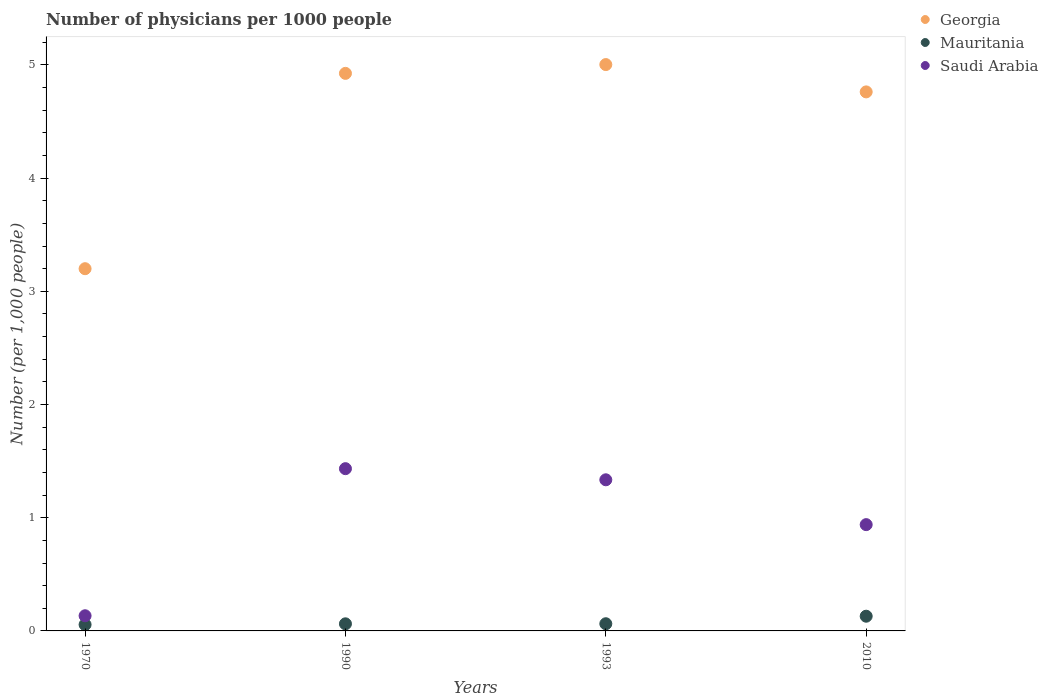How many different coloured dotlines are there?
Your answer should be compact. 3. Is the number of dotlines equal to the number of legend labels?
Offer a very short reply. Yes. What is the number of physicians in Mauritania in 1993?
Provide a succinct answer. 0.06. Across all years, what is the maximum number of physicians in Saudi Arabia?
Keep it short and to the point. 1.43. Across all years, what is the minimum number of physicians in Georgia?
Make the answer very short. 3.2. In which year was the number of physicians in Mauritania maximum?
Make the answer very short. 2010. In which year was the number of physicians in Georgia minimum?
Ensure brevity in your answer.  1970. What is the total number of physicians in Georgia in the graph?
Your answer should be very brief. 17.89. What is the difference between the number of physicians in Saudi Arabia in 1993 and that in 2010?
Your answer should be compact. 0.4. What is the difference between the number of physicians in Saudi Arabia in 1970 and the number of physicians in Georgia in 1990?
Offer a terse response. -4.79. What is the average number of physicians in Saudi Arabia per year?
Offer a very short reply. 0.96. In the year 1990, what is the difference between the number of physicians in Georgia and number of physicians in Mauritania?
Offer a very short reply. 4.86. What is the ratio of the number of physicians in Saudi Arabia in 1970 to that in 2010?
Your answer should be compact. 0.14. Is the difference between the number of physicians in Georgia in 1990 and 1993 greater than the difference between the number of physicians in Mauritania in 1990 and 1993?
Provide a succinct answer. No. What is the difference between the highest and the second highest number of physicians in Mauritania?
Your answer should be very brief. 0.07. What is the difference between the highest and the lowest number of physicians in Georgia?
Ensure brevity in your answer.  1.8. What is the difference between two consecutive major ticks on the Y-axis?
Provide a short and direct response. 1. How are the legend labels stacked?
Your response must be concise. Vertical. What is the title of the graph?
Offer a terse response. Number of physicians per 1000 people. Does "Turkmenistan" appear as one of the legend labels in the graph?
Offer a terse response. No. What is the label or title of the X-axis?
Your response must be concise. Years. What is the label or title of the Y-axis?
Keep it short and to the point. Number (per 1,0 people). What is the Number (per 1,000 people) in Georgia in 1970?
Your response must be concise. 3.2. What is the Number (per 1,000 people) in Mauritania in 1970?
Offer a terse response. 0.06. What is the Number (per 1,000 people) of Saudi Arabia in 1970?
Offer a very short reply. 0.13. What is the Number (per 1,000 people) in Georgia in 1990?
Your answer should be compact. 4.93. What is the Number (per 1,000 people) of Mauritania in 1990?
Offer a terse response. 0.06. What is the Number (per 1,000 people) in Saudi Arabia in 1990?
Offer a terse response. 1.43. What is the Number (per 1,000 people) in Georgia in 1993?
Keep it short and to the point. 5. What is the Number (per 1,000 people) of Mauritania in 1993?
Provide a succinct answer. 0.06. What is the Number (per 1,000 people) of Saudi Arabia in 1993?
Your response must be concise. 1.34. What is the Number (per 1,000 people) in Georgia in 2010?
Make the answer very short. 4.76. What is the Number (per 1,000 people) of Mauritania in 2010?
Provide a short and direct response. 0.13. What is the Number (per 1,000 people) of Saudi Arabia in 2010?
Your response must be concise. 0.94. Across all years, what is the maximum Number (per 1,000 people) of Georgia?
Your answer should be very brief. 5. Across all years, what is the maximum Number (per 1,000 people) of Mauritania?
Offer a very short reply. 0.13. Across all years, what is the maximum Number (per 1,000 people) in Saudi Arabia?
Ensure brevity in your answer.  1.43. Across all years, what is the minimum Number (per 1,000 people) of Georgia?
Your response must be concise. 3.2. Across all years, what is the minimum Number (per 1,000 people) in Mauritania?
Make the answer very short. 0.06. Across all years, what is the minimum Number (per 1,000 people) of Saudi Arabia?
Offer a terse response. 0.13. What is the total Number (per 1,000 people) of Georgia in the graph?
Your answer should be very brief. 17.89. What is the total Number (per 1,000 people) of Mauritania in the graph?
Your response must be concise. 0.31. What is the total Number (per 1,000 people) in Saudi Arabia in the graph?
Your response must be concise. 3.84. What is the difference between the Number (per 1,000 people) of Georgia in 1970 and that in 1990?
Offer a very short reply. -1.73. What is the difference between the Number (per 1,000 people) in Mauritania in 1970 and that in 1990?
Ensure brevity in your answer.  -0.01. What is the difference between the Number (per 1,000 people) of Saudi Arabia in 1970 and that in 1990?
Offer a very short reply. -1.3. What is the difference between the Number (per 1,000 people) of Georgia in 1970 and that in 1993?
Ensure brevity in your answer.  -1.8. What is the difference between the Number (per 1,000 people) of Mauritania in 1970 and that in 1993?
Ensure brevity in your answer.  -0.01. What is the difference between the Number (per 1,000 people) in Saudi Arabia in 1970 and that in 1993?
Offer a terse response. -1.2. What is the difference between the Number (per 1,000 people) in Georgia in 1970 and that in 2010?
Ensure brevity in your answer.  -1.56. What is the difference between the Number (per 1,000 people) of Mauritania in 1970 and that in 2010?
Your answer should be compact. -0.07. What is the difference between the Number (per 1,000 people) of Saudi Arabia in 1970 and that in 2010?
Offer a very short reply. -0.81. What is the difference between the Number (per 1,000 people) in Georgia in 1990 and that in 1993?
Your answer should be compact. -0.08. What is the difference between the Number (per 1,000 people) in Mauritania in 1990 and that in 1993?
Your answer should be compact. -0. What is the difference between the Number (per 1,000 people) in Saudi Arabia in 1990 and that in 1993?
Provide a short and direct response. 0.1. What is the difference between the Number (per 1,000 people) in Georgia in 1990 and that in 2010?
Provide a succinct answer. 0.16. What is the difference between the Number (per 1,000 people) in Mauritania in 1990 and that in 2010?
Offer a very short reply. -0.07. What is the difference between the Number (per 1,000 people) of Saudi Arabia in 1990 and that in 2010?
Your response must be concise. 0.49. What is the difference between the Number (per 1,000 people) of Georgia in 1993 and that in 2010?
Offer a terse response. 0.24. What is the difference between the Number (per 1,000 people) of Mauritania in 1993 and that in 2010?
Your answer should be compact. -0.07. What is the difference between the Number (per 1,000 people) of Saudi Arabia in 1993 and that in 2010?
Ensure brevity in your answer.  0.4. What is the difference between the Number (per 1,000 people) of Georgia in 1970 and the Number (per 1,000 people) of Mauritania in 1990?
Give a very brief answer. 3.14. What is the difference between the Number (per 1,000 people) in Georgia in 1970 and the Number (per 1,000 people) in Saudi Arabia in 1990?
Provide a short and direct response. 1.77. What is the difference between the Number (per 1,000 people) of Mauritania in 1970 and the Number (per 1,000 people) of Saudi Arabia in 1990?
Provide a succinct answer. -1.38. What is the difference between the Number (per 1,000 people) in Georgia in 1970 and the Number (per 1,000 people) in Mauritania in 1993?
Offer a very short reply. 3.14. What is the difference between the Number (per 1,000 people) of Georgia in 1970 and the Number (per 1,000 people) of Saudi Arabia in 1993?
Give a very brief answer. 1.86. What is the difference between the Number (per 1,000 people) in Mauritania in 1970 and the Number (per 1,000 people) in Saudi Arabia in 1993?
Offer a terse response. -1.28. What is the difference between the Number (per 1,000 people) in Georgia in 1970 and the Number (per 1,000 people) in Mauritania in 2010?
Give a very brief answer. 3.07. What is the difference between the Number (per 1,000 people) of Georgia in 1970 and the Number (per 1,000 people) of Saudi Arabia in 2010?
Your answer should be very brief. 2.26. What is the difference between the Number (per 1,000 people) in Mauritania in 1970 and the Number (per 1,000 people) in Saudi Arabia in 2010?
Your answer should be compact. -0.88. What is the difference between the Number (per 1,000 people) of Georgia in 1990 and the Number (per 1,000 people) of Mauritania in 1993?
Your answer should be very brief. 4.86. What is the difference between the Number (per 1,000 people) of Georgia in 1990 and the Number (per 1,000 people) of Saudi Arabia in 1993?
Provide a short and direct response. 3.59. What is the difference between the Number (per 1,000 people) of Mauritania in 1990 and the Number (per 1,000 people) of Saudi Arabia in 1993?
Provide a succinct answer. -1.27. What is the difference between the Number (per 1,000 people) in Georgia in 1990 and the Number (per 1,000 people) in Mauritania in 2010?
Your response must be concise. 4.8. What is the difference between the Number (per 1,000 people) of Georgia in 1990 and the Number (per 1,000 people) of Saudi Arabia in 2010?
Ensure brevity in your answer.  3.99. What is the difference between the Number (per 1,000 people) of Mauritania in 1990 and the Number (per 1,000 people) of Saudi Arabia in 2010?
Make the answer very short. -0.88. What is the difference between the Number (per 1,000 people) of Georgia in 1993 and the Number (per 1,000 people) of Mauritania in 2010?
Offer a terse response. 4.87. What is the difference between the Number (per 1,000 people) of Georgia in 1993 and the Number (per 1,000 people) of Saudi Arabia in 2010?
Your answer should be very brief. 4.06. What is the difference between the Number (per 1,000 people) of Mauritania in 1993 and the Number (per 1,000 people) of Saudi Arabia in 2010?
Your response must be concise. -0.88. What is the average Number (per 1,000 people) of Georgia per year?
Make the answer very short. 4.47. What is the average Number (per 1,000 people) of Mauritania per year?
Ensure brevity in your answer.  0.08. What is the average Number (per 1,000 people) in Saudi Arabia per year?
Give a very brief answer. 0.96. In the year 1970, what is the difference between the Number (per 1,000 people) of Georgia and Number (per 1,000 people) of Mauritania?
Give a very brief answer. 3.14. In the year 1970, what is the difference between the Number (per 1,000 people) in Georgia and Number (per 1,000 people) in Saudi Arabia?
Your answer should be very brief. 3.07. In the year 1970, what is the difference between the Number (per 1,000 people) in Mauritania and Number (per 1,000 people) in Saudi Arabia?
Keep it short and to the point. -0.08. In the year 1990, what is the difference between the Number (per 1,000 people) in Georgia and Number (per 1,000 people) in Mauritania?
Provide a short and direct response. 4.86. In the year 1990, what is the difference between the Number (per 1,000 people) of Georgia and Number (per 1,000 people) of Saudi Arabia?
Your answer should be compact. 3.49. In the year 1990, what is the difference between the Number (per 1,000 people) in Mauritania and Number (per 1,000 people) in Saudi Arabia?
Keep it short and to the point. -1.37. In the year 1993, what is the difference between the Number (per 1,000 people) in Georgia and Number (per 1,000 people) in Mauritania?
Your response must be concise. 4.94. In the year 1993, what is the difference between the Number (per 1,000 people) in Georgia and Number (per 1,000 people) in Saudi Arabia?
Your answer should be compact. 3.67. In the year 1993, what is the difference between the Number (per 1,000 people) in Mauritania and Number (per 1,000 people) in Saudi Arabia?
Offer a terse response. -1.27. In the year 2010, what is the difference between the Number (per 1,000 people) of Georgia and Number (per 1,000 people) of Mauritania?
Ensure brevity in your answer.  4.63. In the year 2010, what is the difference between the Number (per 1,000 people) of Georgia and Number (per 1,000 people) of Saudi Arabia?
Ensure brevity in your answer.  3.82. In the year 2010, what is the difference between the Number (per 1,000 people) of Mauritania and Number (per 1,000 people) of Saudi Arabia?
Provide a short and direct response. -0.81. What is the ratio of the Number (per 1,000 people) in Georgia in 1970 to that in 1990?
Offer a very short reply. 0.65. What is the ratio of the Number (per 1,000 people) of Mauritania in 1970 to that in 1990?
Make the answer very short. 0.89. What is the ratio of the Number (per 1,000 people) in Saudi Arabia in 1970 to that in 1990?
Your answer should be compact. 0.09. What is the ratio of the Number (per 1,000 people) in Georgia in 1970 to that in 1993?
Offer a very short reply. 0.64. What is the ratio of the Number (per 1,000 people) of Mauritania in 1970 to that in 1993?
Your response must be concise. 0.88. What is the ratio of the Number (per 1,000 people) of Saudi Arabia in 1970 to that in 1993?
Give a very brief answer. 0.1. What is the ratio of the Number (per 1,000 people) of Georgia in 1970 to that in 2010?
Your answer should be very brief. 0.67. What is the ratio of the Number (per 1,000 people) of Mauritania in 1970 to that in 2010?
Make the answer very short. 0.43. What is the ratio of the Number (per 1,000 people) in Saudi Arabia in 1970 to that in 2010?
Provide a succinct answer. 0.14. What is the ratio of the Number (per 1,000 people) of Georgia in 1990 to that in 1993?
Offer a very short reply. 0.98. What is the ratio of the Number (per 1,000 people) of Mauritania in 1990 to that in 1993?
Your answer should be compact. 0.99. What is the ratio of the Number (per 1,000 people) of Saudi Arabia in 1990 to that in 1993?
Provide a succinct answer. 1.07. What is the ratio of the Number (per 1,000 people) of Georgia in 1990 to that in 2010?
Your answer should be compact. 1.03. What is the ratio of the Number (per 1,000 people) of Mauritania in 1990 to that in 2010?
Keep it short and to the point. 0.48. What is the ratio of the Number (per 1,000 people) in Saudi Arabia in 1990 to that in 2010?
Offer a very short reply. 1.53. What is the ratio of the Number (per 1,000 people) of Georgia in 1993 to that in 2010?
Your response must be concise. 1.05. What is the ratio of the Number (per 1,000 people) of Mauritania in 1993 to that in 2010?
Make the answer very short. 0.49. What is the ratio of the Number (per 1,000 people) of Saudi Arabia in 1993 to that in 2010?
Keep it short and to the point. 1.42. What is the difference between the highest and the second highest Number (per 1,000 people) in Georgia?
Provide a short and direct response. 0.08. What is the difference between the highest and the second highest Number (per 1,000 people) in Mauritania?
Give a very brief answer. 0.07. What is the difference between the highest and the second highest Number (per 1,000 people) of Saudi Arabia?
Your response must be concise. 0.1. What is the difference between the highest and the lowest Number (per 1,000 people) in Georgia?
Offer a terse response. 1.8. What is the difference between the highest and the lowest Number (per 1,000 people) in Mauritania?
Make the answer very short. 0.07. What is the difference between the highest and the lowest Number (per 1,000 people) of Saudi Arabia?
Your response must be concise. 1.3. 